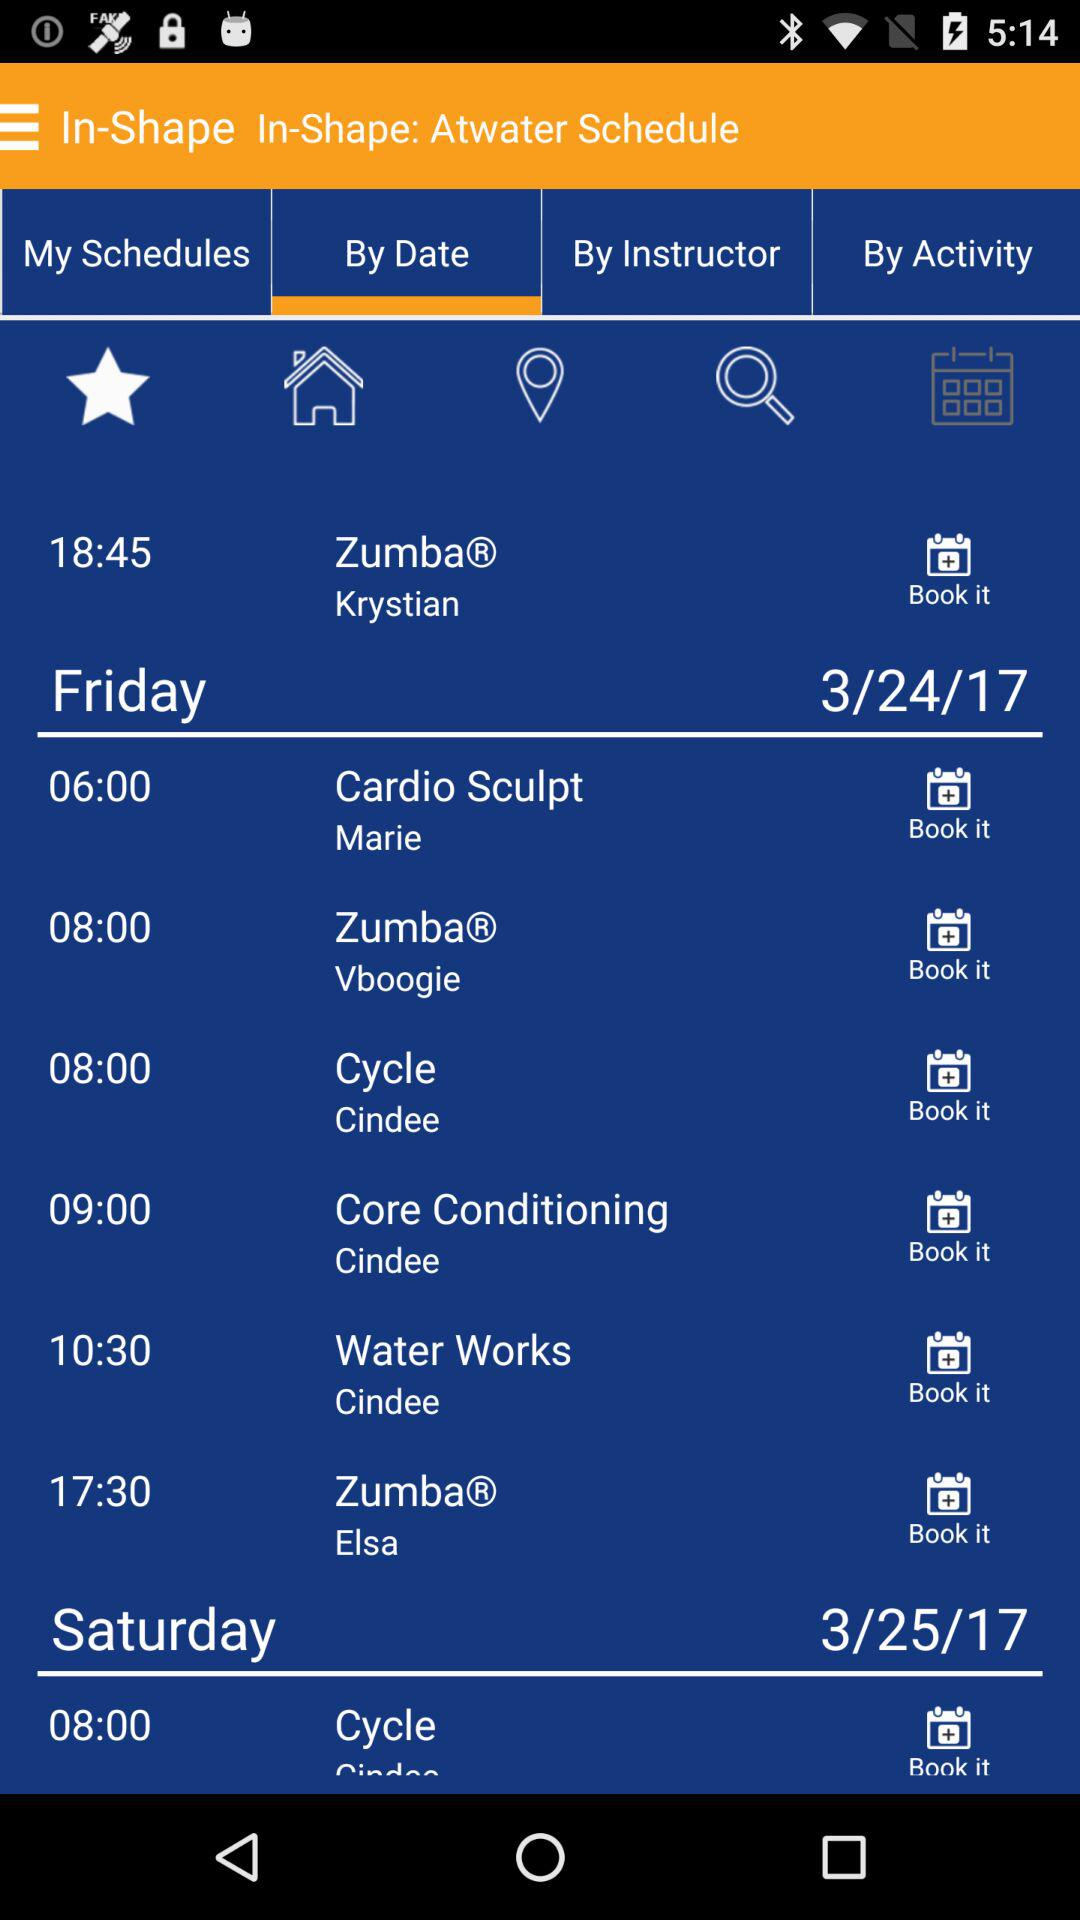What is the time of the first class on Saturday?
Answer the question using a single word or phrase. 08:00 